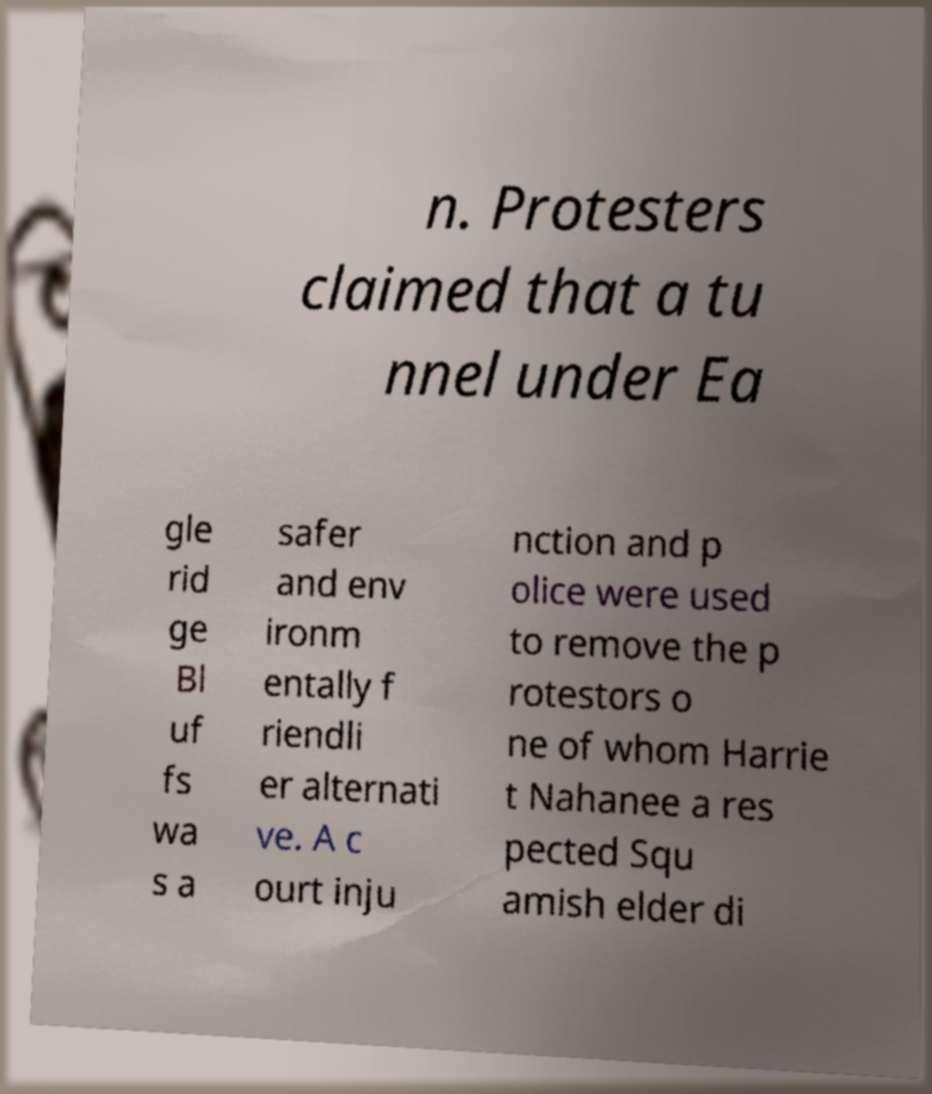For documentation purposes, I need the text within this image transcribed. Could you provide that? n. Protesters claimed that a tu nnel under Ea gle rid ge Bl uf fs wa s a safer and env ironm entally f riendli er alternati ve. A c ourt inju nction and p olice were used to remove the p rotestors o ne of whom Harrie t Nahanee a res pected Squ amish elder di 